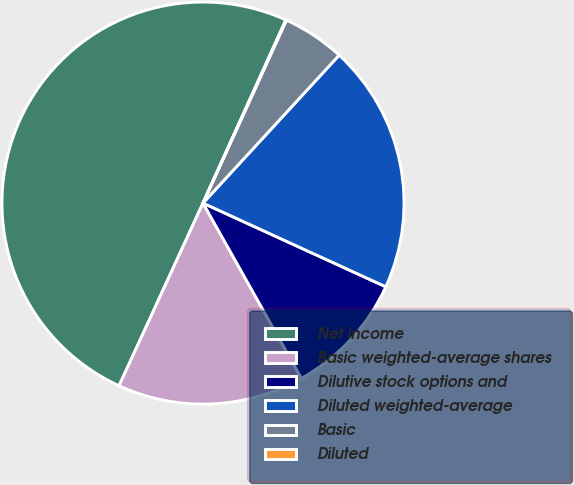Convert chart. <chart><loc_0><loc_0><loc_500><loc_500><pie_chart><fcel>Net income<fcel>Basic weighted-average shares<fcel>Dilutive stock options and<fcel>Diluted weighted-average<fcel>Basic<fcel>Diluted<nl><fcel>49.9%<fcel>15.0%<fcel>10.02%<fcel>19.99%<fcel>5.03%<fcel>0.05%<nl></chart> 